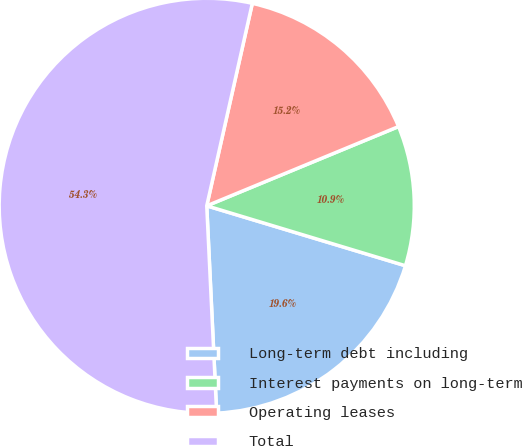Convert chart to OTSL. <chart><loc_0><loc_0><loc_500><loc_500><pie_chart><fcel>Long-term debt including<fcel>Interest payments on long-term<fcel>Operating leases<fcel>Total<nl><fcel>19.58%<fcel>10.9%<fcel>15.24%<fcel>54.29%<nl></chart> 